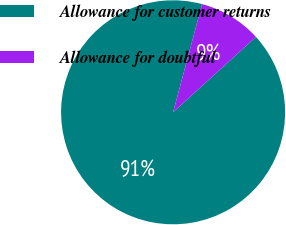<chart> <loc_0><loc_0><loc_500><loc_500><pie_chart><fcel>Allowance for customer returns<fcel>Allowance for doubtful<nl><fcel>90.91%<fcel>9.09%<nl></chart> 